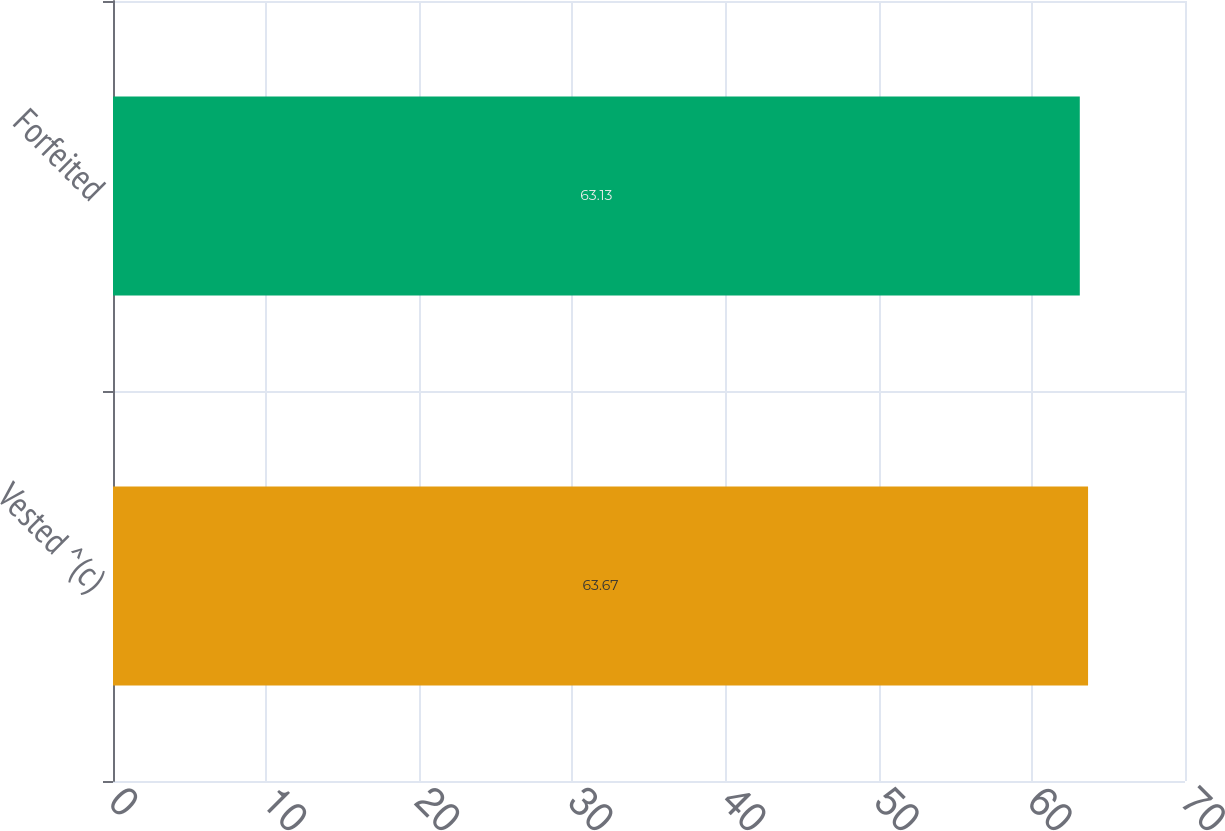<chart> <loc_0><loc_0><loc_500><loc_500><bar_chart><fcel>Vested ^(c)<fcel>Forfeited<nl><fcel>63.67<fcel>63.13<nl></chart> 